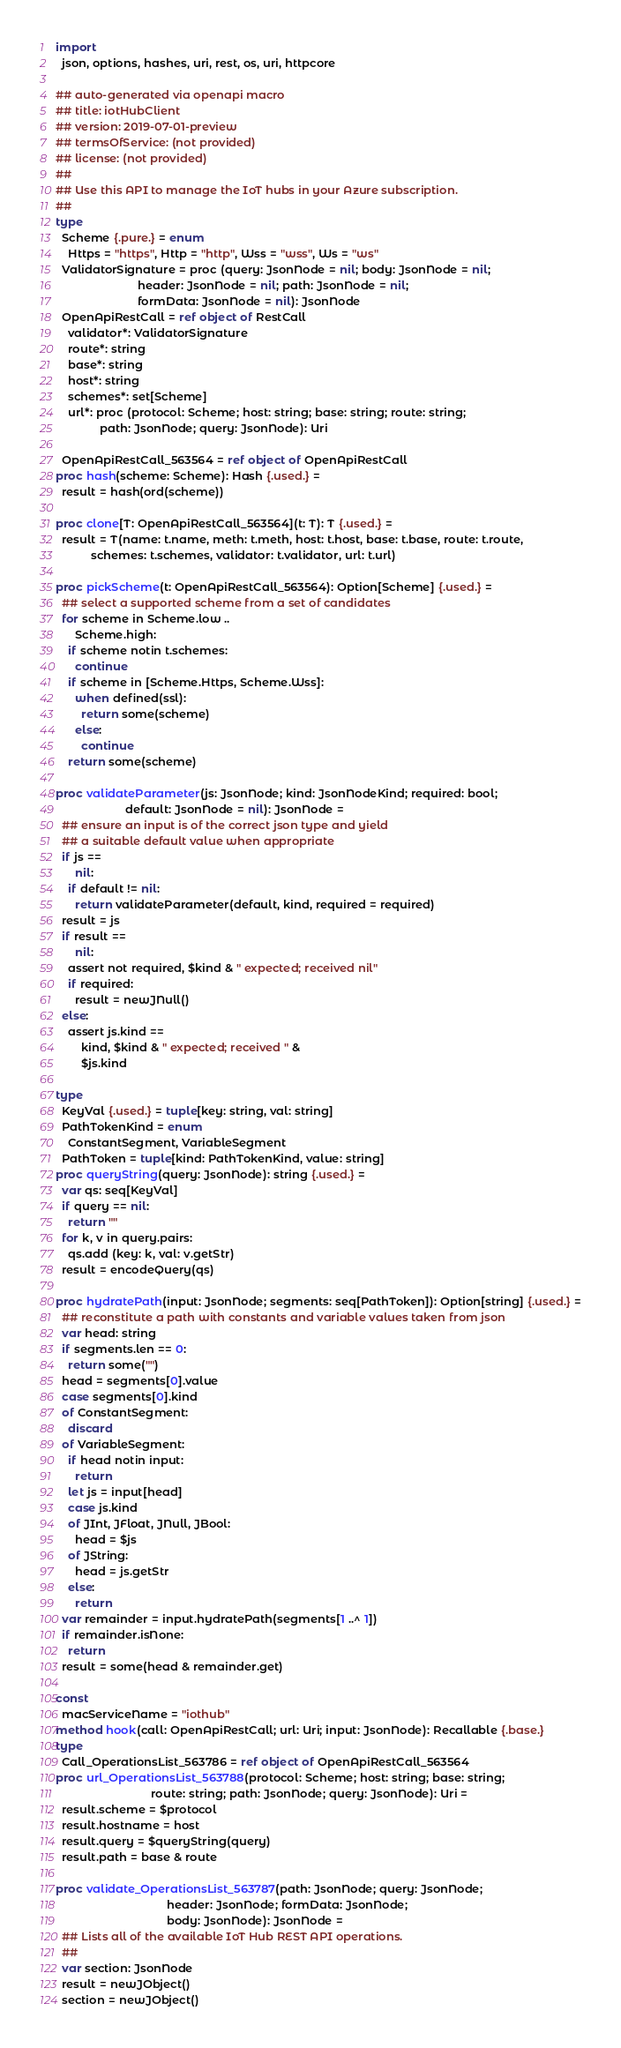<code> <loc_0><loc_0><loc_500><loc_500><_Nim_>
import
  json, options, hashes, uri, rest, os, uri, httpcore

## auto-generated via openapi macro
## title: iotHubClient
## version: 2019-07-01-preview
## termsOfService: (not provided)
## license: (not provided)
## 
## Use this API to manage the IoT hubs in your Azure subscription.
## 
type
  Scheme {.pure.} = enum
    Https = "https", Http = "http", Wss = "wss", Ws = "ws"
  ValidatorSignature = proc (query: JsonNode = nil; body: JsonNode = nil;
                          header: JsonNode = nil; path: JsonNode = nil;
                          formData: JsonNode = nil): JsonNode
  OpenApiRestCall = ref object of RestCall
    validator*: ValidatorSignature
    route*: string
    base*: string
    host*: string
    schemes*: set[Scheme]
    url*: proc (protocol: Scheme; host: string; base: string; route: string;
              path: JsonNode; query: JsonNode): Uri

  OpenApiRestCall_563564 = ref object of OpenApiRestCall
proc hash(scheme: Scheme): Hash {.used.} =
  result = hash(ord(scheme))

proc clone[T: OpenApiRestCall_563564](t: T): T {.used.} =
  result = T(name: t.name, meth: t.meth, host: t.host, base: t.base, route: t.route,
           schemes: t.schemes, validator: t.validator, url: t.url)

proc pickScheme(t: OpenApiRestCall_563564): Option[Scheme] {.used.} =
  ## select a supported scheme from a set of candidates
  for scheme in Scheme.low ..
      Scheme.high:
    if scheme notin t.schemes:
      continue
    if scheme in [Scheme.Https, Scheme.Wss]:
      when defined(ssl):
        return some(scheme)
      else:
        continue
    return some(scheme)

proc validateParameter(js: JsonNode; kind: JsonNodeKind; required: bool;
                      default: JsonNode = nil): JsonNode =
  ## ensure an input is of the correct json type and yield
  ## a suitable default value when appropriate
  if js ==
      nil:
    if default != nil:
      return validateParameter(default, kind, required = required)
  result = js
  if result ==
      nil:
    assert not required, $kind & " expected; received nil"
    if required:
      result = newJNull()
  else:
    assert js.kind ==
        kind, $kind & " expected; received " &
        $js.kind

type
  KeyVal {.used.} = tuple[key: string, val: string]
  PathTokenKind = enum
    ConstantSegment, VariableSegment
  PathToken = tuple[kind: PathTokenKind, value: string]
proc queryString(query: JsonNode): string {.used.} =
  var qs: seq[KeyVal]
  if query == nil:
    return ""
  for k, v in query.pairs:
    qs.add (key: k, val: v.getStr)
  result = encodeQuery(qs)

proc hydratePath(input: JsonNode; segments: seq[PathToken]): Option[string] {.used.} =
  ## reconstitute a path with constants and variable values taken from json
  var head: string
  if segments.len == 0:
    return some("")
  head = segments[0].value
  case segments[0].kind
  of ConstantSegment:
    discard
  of VariableSegment:
    if head notin input:
      return
    let js = input[head]
    case js.kind
    of JInt, JFloat, JNull, JBool:
      head = $js
    of JString:
      head = js.getStr
    else:
      return
  var remainder = input.hydratePath(segments[1 ..^ 1])
  if remainder.isNone:
    return
  result = some(head & remainder.get)

const
  macServiceName = "iothub"
method hook(call: OpenApiRestCall; url: Uri; input: JsonNode): Recallable {.base.}
type
  Call_OperationsList_563786 = ref object of OpenApiRestCall_563564
proc url_OperationsList_563788(protocol: Scheme; host: string; base: string;
                              route: string; path: JsonNode; query: JsonNode): Uri =
  result.scheme = $protocol
  result.hostname = host
  result.query = $queryString(query)
  result.path = base & route

proc validate_OperationsList_563787(path: JsonNode; query: JsonNode;
                                   header: JsonNode; formData: JsonNode;
                                   body: JsonNode): JsonNode =
  ## Lists all of the available IoT Hub REST API operations.
  ## 
  var section: JsonNode
  result = newJObject()
  section = newJObject()</code> 